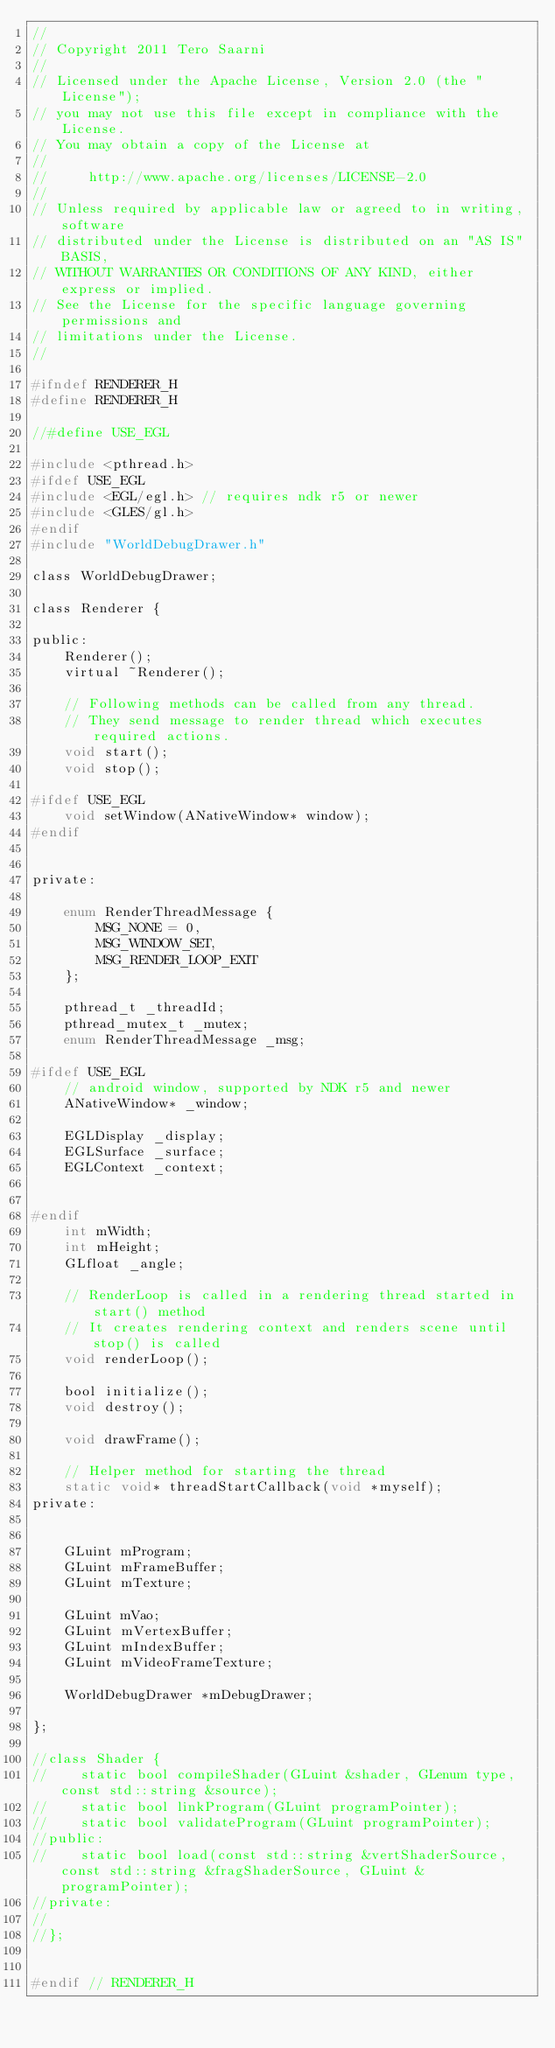Convert code to text. <code><loc_0><loc_0><loc_500><loc_500><_C_>//
// Copyright 2011 Tero Saarni
//
// Licensed under the Apache License, Version 2.0 (the "License");
// you may not use this file except in compliance with the License.
// You may obtain a copy of the License at
//
//     http://www.apache.org/licenses/LICENSE-2.0
//
// Unless required by applicable law or agreed to in writing, software
// distributed under the License is distributed on an "AS IS" BASIS,
// WITHOUT WARRANTIES OR CONDITIONS OF ANY KIND, either express or implied.
// See the License for the specific language governing permissions and
// limitations under the License.
//

#ifndef RENDERER_H
#define RENDERER_H

//#define USE_EGL

#include <pthread.h>
#ifdef USE_EGL
#include <EGL/egl.h> // requires ndk r5 or newer
#include <GLES/gl.h>
#endif
#include "WorldDebugDrawer.h"

class WorldDebugDrawer;

class Renderer {

public:
    Renderer();
    virtual ~Renderer();

    // Following methods can be called from any thread.
    // They send message to render thread which executes required actions.
    void start();
    void stop();

#ifdef USE_EGL
    void setWindow(ANativeWindow* window);
#endif


private:

    enum RenderThreadMessage {
        MSG_NONE = 0,
        MSG_WINDOW_SET,
        MSG_RENDER_LOOP_EXIT
    };

    pthread_t _threadId;
    pthread_mutex_t _mutex;
    enum RenderThreadMessage _msg;

#ifdef USE_EGL
    // android window, supported by NDK r5 and newer
    ANativeWindow* _window;

    EGLDisplay _display;
    EGLSurface _surface;
    EGLContext _context;


#endif
    int mWidth;
    int mHeight;
    GLfloat _angle;

    // RenderLoop is called in a rendering thread started in start() method
    // It creates rendering context and renders scene until stop() is called
    void renderLoop();

    bool initialize();
    void destroy();

    void drawFrame();

    // Helper method for starting the thread
    static void* threadStartCallback(void *myself);
private:


    GLuint mProgram;
    GLuint mFrameBuffer;
    GLuint mTexture;

    GLuint mVao;
    GLuint mVertexBuffer;
    GLuint mIndexBuffer;
    GLuint mVideoFrameTexture;

    WorldDebugDrawer *mDebugDrawer;

};

//class Shader {
//    static bool compileShader(GLuint &shader, GLenum type, const std::string &source);
//    static bool linkProgram(GLuint programPointer);
//    static bool validateProgram(GLuint programPointer);
//public:
//    static bool load(const std::string &vertShaderSource, const std::string &fragShaderSource, GLuint &programPointer);
//private:
//
//};


#endif // RENDERER_H
</code> 